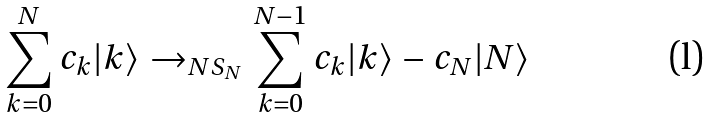<formula> <loc_0><loc_0><loc_500><loc_500>\sum _ { k = 0 } ^ { N } c _ { k } | k \rangle \rightarrow _ { N S _ { N } } \sum _ { k = 0 } ^ { N - 1 } c _ { k } | k \rangle - c _ { N } | N \rangle</formula> 